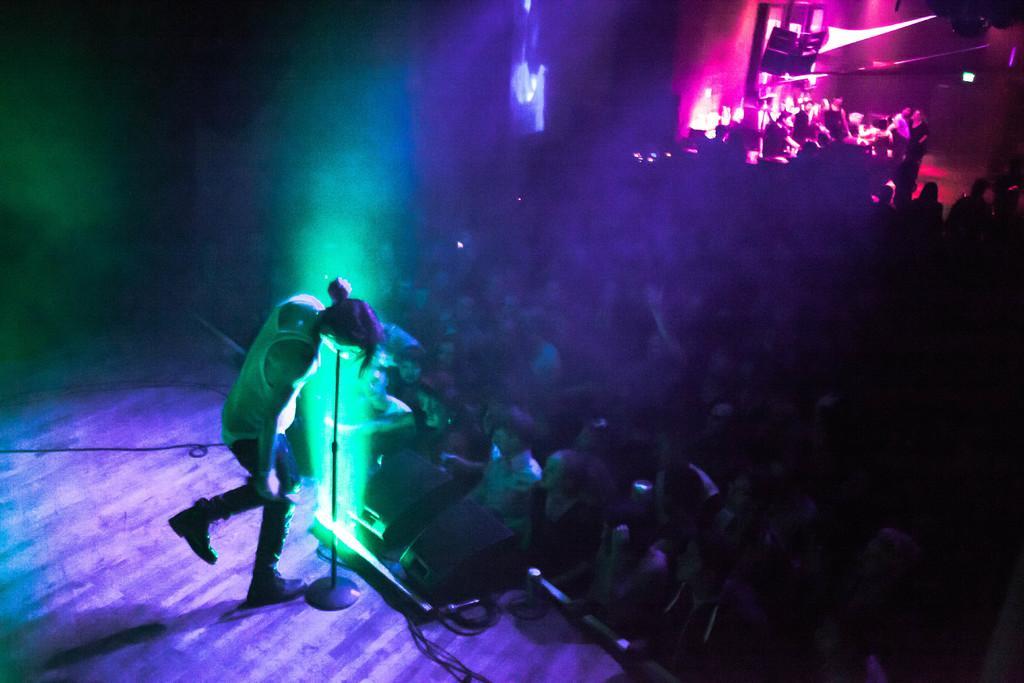How would you summarize this image in a sentence or two? In this image, we can see a singer on the stage with a crowd. 